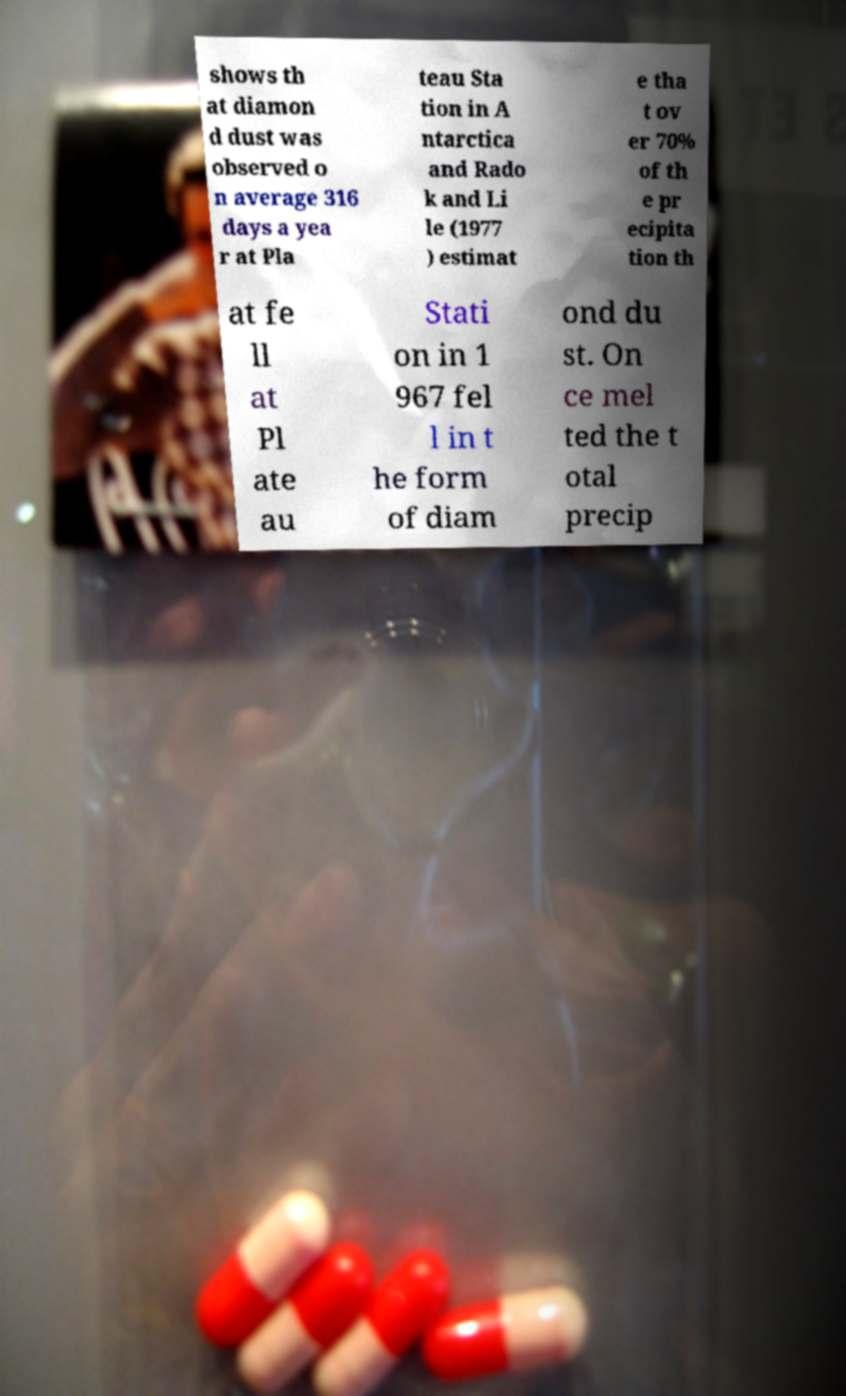Please identify and transcribe the text found in this image. shows th at diamon d dust was observed o n average 316 days a yea r at Pla teau Sta tion in A ntarctica and Rado k and Li le (1977 ) estimat e tha t ov er 70% of th e pr ecipita tion th at fe ll at Pl ate au Stati on in 1 967 fel l in t he form of diam ond du st. On ce mel ted the t otal precip 